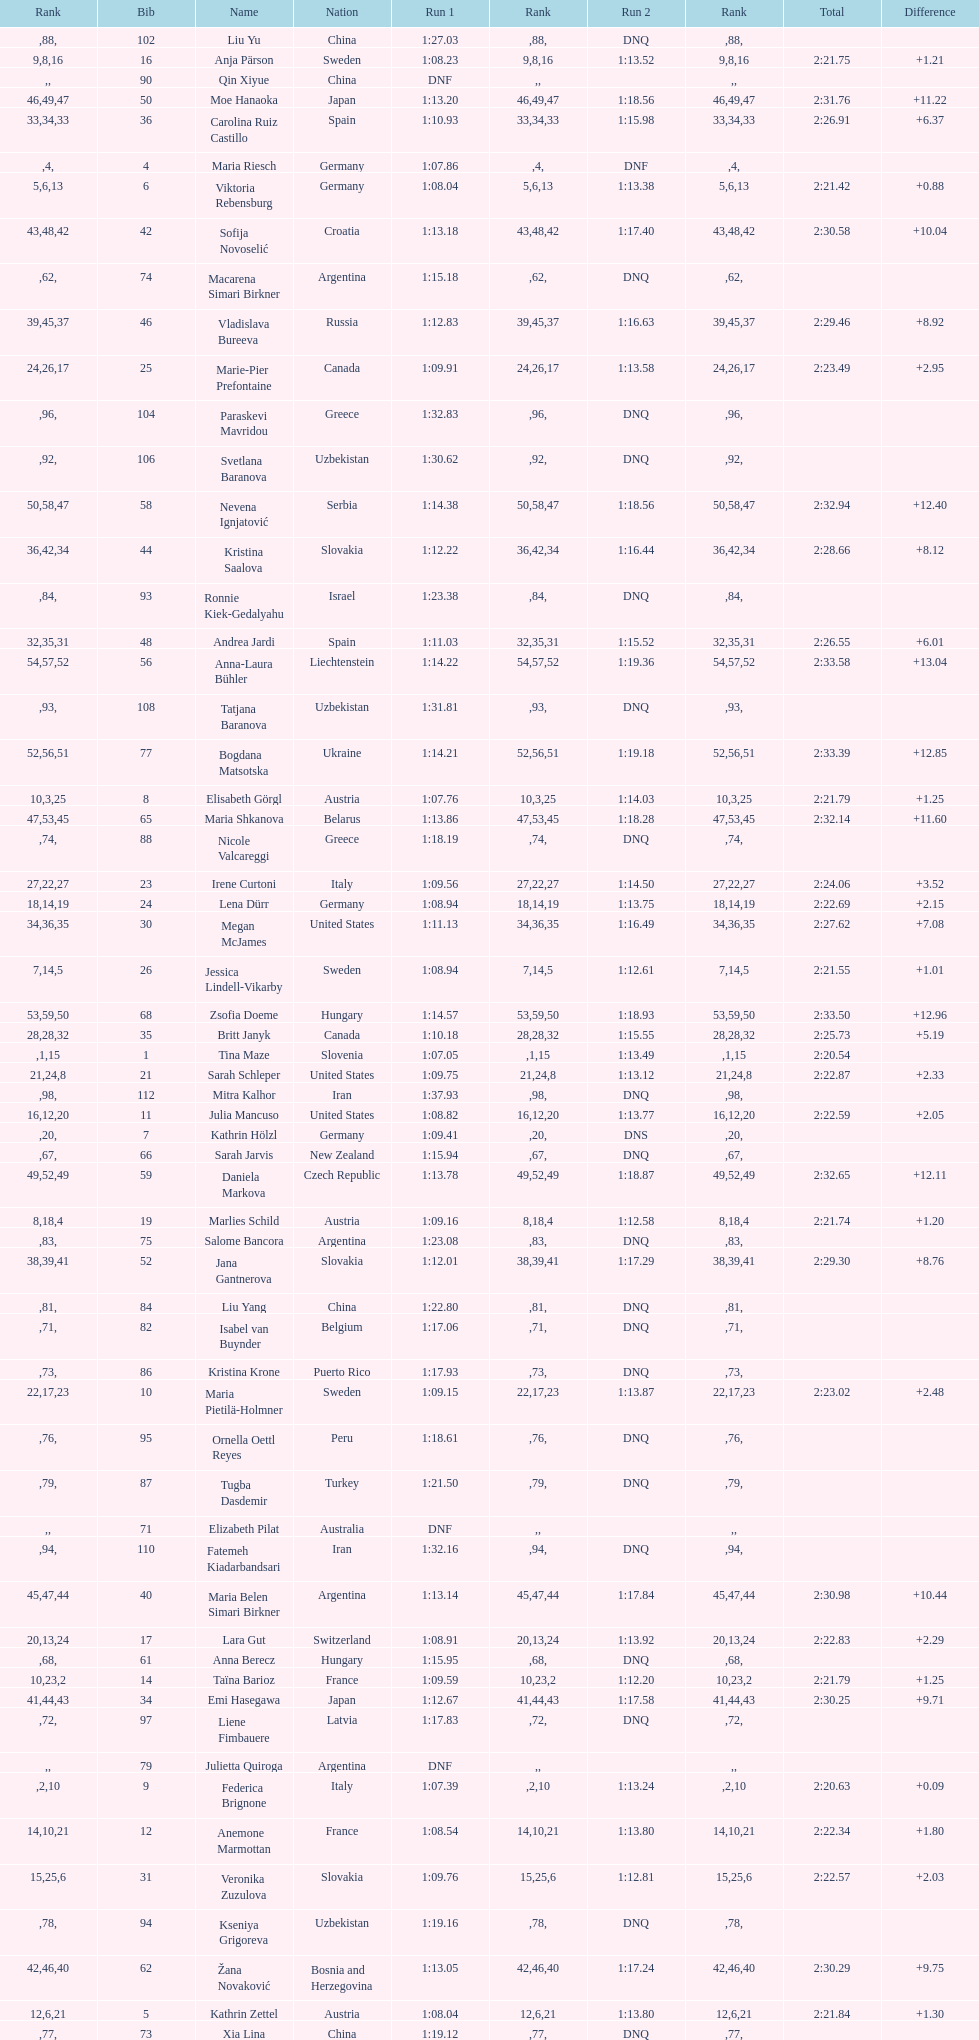Would you be able to parse every entry in this table? {'header': ['Rank', 'Bib', 'Name', 'Nation', 'Run 1', 'Rank', 'Run 2', 'Rank', 'Total', 'Difference'], 'rows': [['', '102', 'Liu Yu', 'China', '1:27.03', '88', 'DNQ', '', '', ''], ['9', '16', 'Anja Pärson', 'Sweden', '1:08.23', '8', '1:13.52', '16', '2:21.75', '+1.21'], ['', '90', 'Qin Xiyue', 'China', 'DNF', '', '', '', '', ''], ['46', '50', 'Moe Hanaoka', 'Japan', '1:13.20', '49', '1:18.56', '47', '2:31.76', '+11.22'], ['33', '36', 'Carolina Ruiz Castillo', 'Spain', '1:10.93', '34', '1:15.98', '33', '2:26.91', '+6.37'], ['', '4', 'Maria Riesch', 'Germany', '1:07.86', '4', 'DNF', '', '', ''], ['5', '6', 'Viktoria Rebensburg', 'Germany', '1:08.04', '6', '1:13.38', '13', '2:21.42', '+0.88'], ['43', '42', 'Sofija Novoselić', 'Croatia', '1:13.18', '48', '1:17.40', '42', '2:30.58', '+10.04'], ['', '74', 'Macarena Simari Birkner', 'Argentina', '1:15.18', '62', 'DNQ', '', '', ''], ['39', '46', 'Vladislava Bureeva', 'Russia', '1:12.83', '45', '1:16.63', '37', '2:29.46', '+8.92'], ['24', '25', 'Marie-Pier Prefontaine', 'Canada', '1:09.91', '26', '1:13.58', '17', '2:23.49', '+2.95'], ['', '104', 'Paraskevi Mavridou', 'Greece', '1:32.83', '96', 'DNQ', '', '', ''], ['', '106', 'Svetlana Baranova', 'Uzbekistan', '1:30.62', '92', 'DNQ', '', '', ''], ['50', '58', 'Nevena Ignjatović', 'Serbia', '1:14.38', '58', '1:18.56', '47', '2:32.94', '+12.40'], ['36', '44', 'Kristina Saalova', 'Slovakia', '1:12.22', '42', '1:16.44', '34', '2:28.66', '+8.12'], ['', '93', 'Ronnie Kiek-Gedalyahu', 'Israel', '1:23.38', '84', 'DNQ', '', '', ''], ['32', '48', 'Andrea Jardi', 'Spain', '1:11.03', '35', '1:15.52', '31', '2:26.55', '+6.01'], ['54', '56', 'Anna-Laura Bühler', 'Liechtenstein', '1:14.22', '57', '1:19.36', '52', '2:33.58', '+13.04'], ['', '108', 'Tatjana Baranova', 'Uzbekistan', '1:31.81', '93', 'DNQ', '', '', ''], ['52', '77', 'Bogdana Matsotska', 'Ukraine', '1:14.21', '56', '1:19.18', '51', '2:33.39', '+12.85'], ['10', '8', 'Elisabeth Görgl', 'Austria', '1:07.76', '3', '1:14.03', '25', '2:21.79', '+1.25'], ['47', '65', 'Maria Shkanova', 'Belarus', '1:13.86', '53', '1:18.28', '45', '2:32.14', '+11.60'], ['', '88', 'Nicole Valcareggi', 'Greece', '1:18.19', '74', 'DNQ', '', '', ''], ['27', '23', 'Irene Curtoni', 'Italy', '1:09.56', '22', '1:14.50', '27', '2:24.06', '+3.52'], ['18', '24', 'Lena Dürr', 'Germany', '1:08.94', '14', '1:13.75', '19', '2:22.69', '+2.15'], ['34', '30', 'Megan McJames', 'United States', '1:11.13', '36', '1:16.49', '35', '2:27.62', '+7.08'], ['7', '26', 'Jessica Lindell-Vikarby', 'Sweden', '1:08.94', '14', '1:12.61', '5', '2:21.55', '+1.01'], ['53', '68', 'Zsofia Doeme', 'Hungary', '1:14.57', '59', '1:18.93', '50', '2:33.50', '+12.96'], ['28', '35', 'Britt Janyk', 'Canada', '1:10.18', '28', '1:15.55', '32', '2:25.73', '+5.19'], ['', '1', 'Tina Maze', 'Slovenia', '1:07.05', '1', '1:13.49', '15', '2:20.54', ''], ['21', '21', 'Sarah Schleper', 'United States', '1:09.75', '24', '1:13.12', '8', '2:22.87', '+2.33'], ['', '112', 'Mitra Kalhor', 'Iran', '1:37.93', '98', 'DNQ', '', '', ''], ['16', '11', 'Julia Mancuso', 'United States', '1:08.82', '12', '1:13.77', '20', '2:22.59', '+2.05'], ['', '7', 'Kathrin Hölzl', 'Germany', '1:09.41', '20', 'DNS', '', '', ''], ['', '66', 'Sarah Jarvis', 'New Zealand', '1:15.94', '67', 'DNQ', '', '', ''], ['49', '59', 'Daniela Markova', 'Czech Republic', '1:13.78', '52', '1:18.87', '49', '2:32.65', '+12.11'], ['8', '19', 'Marlies Schild', 'Austria', '1:09.16', '18', '1:12.58', '4', '2:21.74', '+1.20'], ['', '75', 'Salome Bancora', 'Argentina', '1:23.08', '83', 'DNQ', '', '', ''], ['38', '52', 'Jana Gantnerova', 'Slovakia', '1:12.01', '39', '1:17.29', '41', '2:29.30', '+8.76'], ['', '84', 'Liu Yang', 'China', '1:22.80', '81', 'DNQ', '', '', ''], ['', '82', 'Isabel van Buynder', 'Belgium', '1:17.06', '71', 'DNQ', '', '', ''], ['', '86', 'Kristina Krone', 'Puerto Rico', '1:17.93', '73', 'DNQ', '', '', ''], ['22', '10', 'Maria Pietilä-Holmner', 'Sweden', '1:09.15', '17', '1:13.87', '23', '2:23.02', '+2.48'], ['', '95', 'Ornella Oettl Reyes', 'Peru', '1:18.61', '76', 'DNQ', '', '', ''], ['', '87', 'Tugba Dasdemir', 'Turkey', '1:21.50', '79', 'DNQ', '', '', ''], ['', '71', 'Elizabeth Pilat', 'Australia', 'DNF', '', '', '', '', ''], ['', '110', 'Fatemeh Kiadarbandsari', 'Iran', '1:32.16', '94', 'DNQ', '', '', ''], ['45', '40', 'Maria Belen Simari Birkner', 'Argentina', '1:13.14', '47', '1:17.84', '44', '2:30.98', '+10.44'], ['20', '17', 'Lara Gut', 'Switzerland', '1:08.91', '13', '1:13.92', '24', '2:22.83', '+2.29'], ['', '61', 'Anna Berecz', 'Hungary', '1:15.95', '68', 'DNQ', '', '', ''], ['10', '14', 'Taïna Barioz', 'France', '1:09.59', '23', '1:12.20', '2', '2:21.79', '+1.25'], ['41', '34', 'Emi Hasegawa', 'Japan', '1:12.67', '44', '1:17.58', '43', '2:30.25', '+9.71'], ['', '97', 'Liene Fimbauere', 'Latvia', '1:17.83', '72', 'DNQ', '', '', ''], ['', '79', 'Julietta Quiroga', 'Argentina', 'DNF', '', '', '', '', ''], ['', '9', 'Federica Brignone', 'Italy', '1:07.39', '2', '1:13.24', '10', '2:20.63', '+0.09'], ['14', '12', 'Anemone Marmottan', 'France', '1:08.54', '10', '1:13.80', '21', '2:22.34', '+1.80'], ['15', '31', 'Veronika Zuzulova', 'Slovakia', '1:09.76', '25', '1:12.81', '6', '2:22.57', '+2.03'], ['', '94', 'Kseniya Grigoreva', 'Uzbekistan', '1:19.16', '78', 'DNQ', '', '', ''], ['42', '62', 'Žana Novaković', 'Bosnia and Herzegovina', '1:13.05', '46', '1:17.24', '40', '2:30.29', '+9.75'], ['12', '5', 'Kathrin Zettel', 'Austria', '1:08.04', '6', '1:13.80', '21', '2:21.84', '+1.30'], ['', '73', 'Xia Lina', 'China', '1:19.12', '77', 'DNQ', '', '', ''], ['55', '67', 'Martina Dubovska', 'Czech Republic', '1:14.62', '60', '1:19.95', '55', '2:34.57', '+14.03'], ['', '53', 'Karolina Chrapek', 'Poland', 'DNF', '', '', '', '', ''], ['51', '80', 'Maria Kirkova', 'Bulgaria', '1:13.70', '51', '1:19.56', '54', '2:33.26', '+12.72'], ['37', '51', 'Katerina Paulathova', 'Czech Republic', '1:12.10', '41', '1:16.71', '38', '2:28.81', '+8.27'], ['', '54', 'Mireia Gutierrez', 'Andorra', 'DNF', '', '', '', '', ''], ['', '99', 'Marjan Kalhor', 'Iran', '1:34.94', '97', 'DNQ', '', '', ''], ['', '92', 'Malene Madsen', 'Denmark', '1:22.25', '80', 'DNQ', '', '', ''], ['', '103', 'Szelina Hellner', 'Hungary', '1:27.27', '90', 'DNQ', '', '', ''], ['29', '41', 'Wendy Holdener', 'Switzerland', '1:10.63', '32', '1:15.17', '30', '2:25.80', '+5.26'], ['23', '22', 'Marie-Michèle Gagnon', 'Canada', '1:09.95', '27', '1:13.37', '12', '2:23.32', '+2.78'], ['', '100', 'Sophie Fjellvang-Sølling', 'Denmark', '1:18.37', '75', 'DNQ', '', '', ''], ['19', '29', 'Anne-Sophie Barthet', 'France', '1:09.55', '21', '1:13.18', '9', '2:22.73', '+2.19'], ['', '113', 'Anne Libak Nielsen', 'Denmark', '1:25.08', '86', 'DNQ', '', '', ''], ['', '3', 'Tessa Worley', 'France', '1:09.17', '19', '1:11.85', '1', '2:21.02', '+0.48'], ['35', '43', 'Denise Feierabend', 'Switzerland', '1:11.37', '38', '1:16.61', '36', '2:27.98', '+7.44'], ['17', '27', 'Sara Hector', 'Sweden', '1:10.37', '30', '1:12.30', '3', '2:22.67', '+2.13'], ['', '111', 'Sarah Ekmekejian', 'Lebanon', '1:42.22', '100', 'DNQ', '', '', ''], ['6', '13', 'Manuela Mölgg', 'Italy', '1:07.99', '5', '1:13.44', '14', '2:21.43', '+0.89'], ['', '78', 'Nino Tsiklauri', 'Georgia', '1:15.54', '66', 'DNQ', '', '', ''], ['25', '15', 'Andrea Fischbacher', 'Austria', '1:09.13', '16', '1:14.40', '26', '2:23.53', '+2.99'], ['', '45', 'Tea Palić', 'Croatia', '1:14.73', '61', 'DNQ', '', '', ''], ['26', '39', 'Marusa Ferk', 'Slovenia', '1:10.35', '29', '1:13.70', '18', '2:24.05', '+3.51'], ['', '116', 'Siranush Maghakyan', 'Armenia', 'DNF', '', '', '', '', ''], ['', '89', 'Evija Benhena', 'Latvia', 'DNF', '', '', '', '', ''], ['', '72', 'Lavinia Chrystal', 'Australia', '1:15.35', '63', 'DNQ', '', '', ''], ['30', '28', 'Veronika Staber', 'Germany', '1:10.80', '33', '1:15.16', '28', '2:25.96', '+5.42'], ['', '107', 'Ziba Kalhor', 'Iran', '1:32.64', '95', 'DNQ', '', '', ''], ['13', '2', 'Tanja Poutiainen', 'Finland', '1:08.59', '11', '1:13.29', '11', '2:21.88', '+1.34'], ['', '33', 'Agniezska Gasienica Daniel', 'Poland', 'DNF', '', '', '', '', ''], ['', '115', 'Laura Bauer', 'South Africa', '1:42.19', '99', 'DNQ', '', '', ''], ['', '114', 'Irina Volkova', 'Kyrgyzstan', '1:29.73', '91', 'DNQ', '', '', ''], ['31', '32', 'María José Rienda', 'Spain', '1:11.24', '37', '1:15.13', '29', '2:26.37', '+5.83'], ['', '64', 'Aleksandra Klus', 'Poland', '1:15.41', '65', 'DNQ', '', '', ''], ['', '91', 'Yom Hirshfeld', 'Israel', '1:22.87', '82', 'DNQ', '', '', ''], ['', '76', 'Katrin Kristjansdottir', 'Iceland', 'DNF', '', '', '', '', ''], ['', '18', 'Fabienne Suter', 'Switzerland', 'DNS', '', '', '', '', ''], ['44', '49', 'Jana Skvarkova', 'Slovakia', '1:13.63', '50', '1:17.22', '39', '2:30.85', '+10.31'], ['', '98', 'Maja Klepić', 'Bosnia and Herzegovina', 'DNS', '', '', '', '', ''], ['', '38', 'Rebecca Bühler', 'Liechtenstein', '1:12.03', '40', 'DNF', '', '', ''], ['', '101', 'Sophia Ralli', 'Greece', 'DNF', '', '', '', '', ''], ['', '70', 'Maya Harrisson', 'Brazil', 'DNF', '', '', '', '', ''], ['', '60', 'Tereza Kmochova', 'Czech Republic', 'DNF', '', '', '', '', ''], ['', '81', 'Lelde Gasuna', 'Latvia', '1:15.37', '64', 'DNQ', '', '', ''], ['', '47', 'Vanessa Schädler', 'Liechtenstein', '1:12.47', '43', 'DNF', '', '', ''], ['', '109', 'Lida Zvoznikova', 'Kyrgyzstan', '1:27.17', '89', 'DNQ', '', '', ''], ['40', '37', 'Mizue Hoshi', 'Japan', '1:10.43', '31', '1:19.53', '53', '2:29.96', '+9.42'], ['', '96', 'Chiara Marano', 'Brazil', '1:24.16', '85', 'DNQ', '', '', ''], ['', '57', 'Brittany Phelan', 'Canada', 'DNF', '', '', '', '', ''], ['', '69', 'Iris Gudmundsdottir', 'Iceland', '1:13.93', '55', 'DNF', '', '', ''], ['', '85', 'Iulia Petruta Craciun', 'Romania', '1:16.80', '70', 'DNQ', '', '', ''], ['', '105', 'Donata Hellner', 'Hungary', '1:26.97', '87', 'DNQ', '', '', ''], ['4', '20', 'Denise Karbon', 'Italy', '1:08.24', '9', '1:13.04', '7', '2:21.28', '+0.74'], ['48', '55', 'Katarzyna Karasinska', 'Poland', '1:13.92', '54', '1:18.46', '46', '2:32.38', '+11.84'], ['', '83', 'Sandra-Elena Narea', 'Romania', '1:16.67', '69', 'DNQ', '', '', ''], ['', '63', 'Michelle van Herwerden', 'Netherlands', 'DNF', '', '', '', '', '']]} Who finished next after federica brignone? Tessa Worley. 